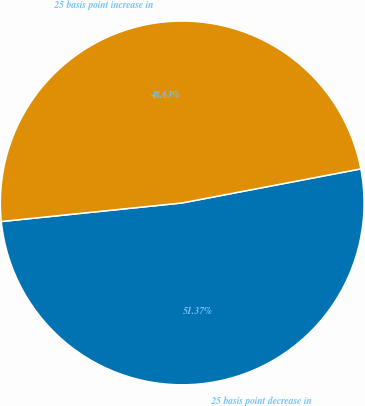Convert chart to OTSL. <chart><loc_0><loc_0><loc_500><loc_500><pie_chart><fcel>25 basis point decrease in<fcel>25 basis point increase in<nl><fcel>51.37%<fcel>48.63%<nl></chart> 